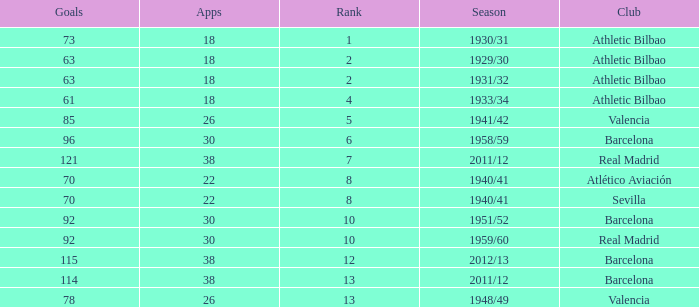Who was the club having less than 22 apps and ranked less than 2? Athletic Bilbao. Help me parse the entirety of this table. {'header': ['Goals', 'Apps', 'Rank', 'Season', 'Club'], 'rows': [['73', '18', '1', '1930/31', 'Athletic Bilbao'], ['63', '18', '2', '1929/30', 'Athletic Bilbao'], ['63', '18', '2', '1931/32', 'Athletic Bilbao'], ['61', '18', '4', '1933/34', 'Athletic Bilbao'], ['85', '26', '5', '1941/42', 'Valencia'], ['96', '30', '6', '1958/59', 'Barcelona'], ['121', '38', '7', '2011/12', 'Real Madrid'], ['70', '22', '8', '1940/41', 'Atlético Aviación'], ['70', '22', '8', '1940/41', 'Sevilla'], ['92', '30', '10', '1951/52', 'Barcelona'], ['92', '30', '10', '1959/60', 'Real Madrid'], ['115', '38', '12', '2012/13', 'Barcelona'], ['114', '38', '13', '2011/12', 'Barcelona'], ['78', '26', '13', '1948/49', 'Valencia']]} 